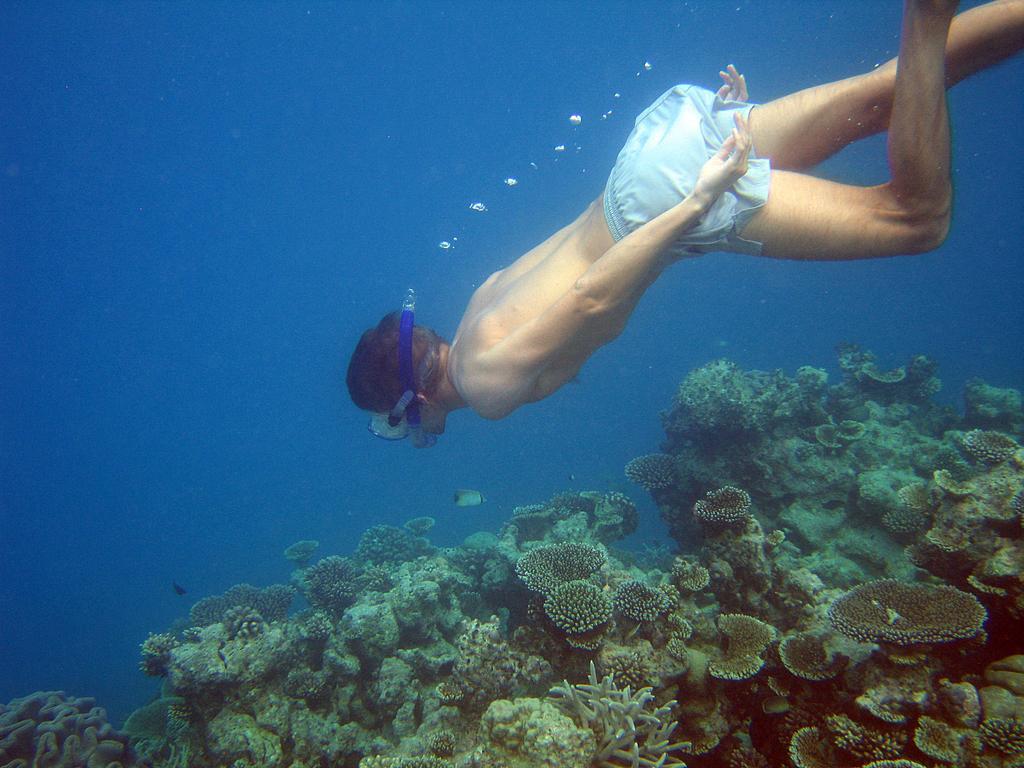Could you give a brief overview of what you see in this image? There is a person swimming in the water and wearing a snorkel. In the water there are corals. Also there are bubbles. 